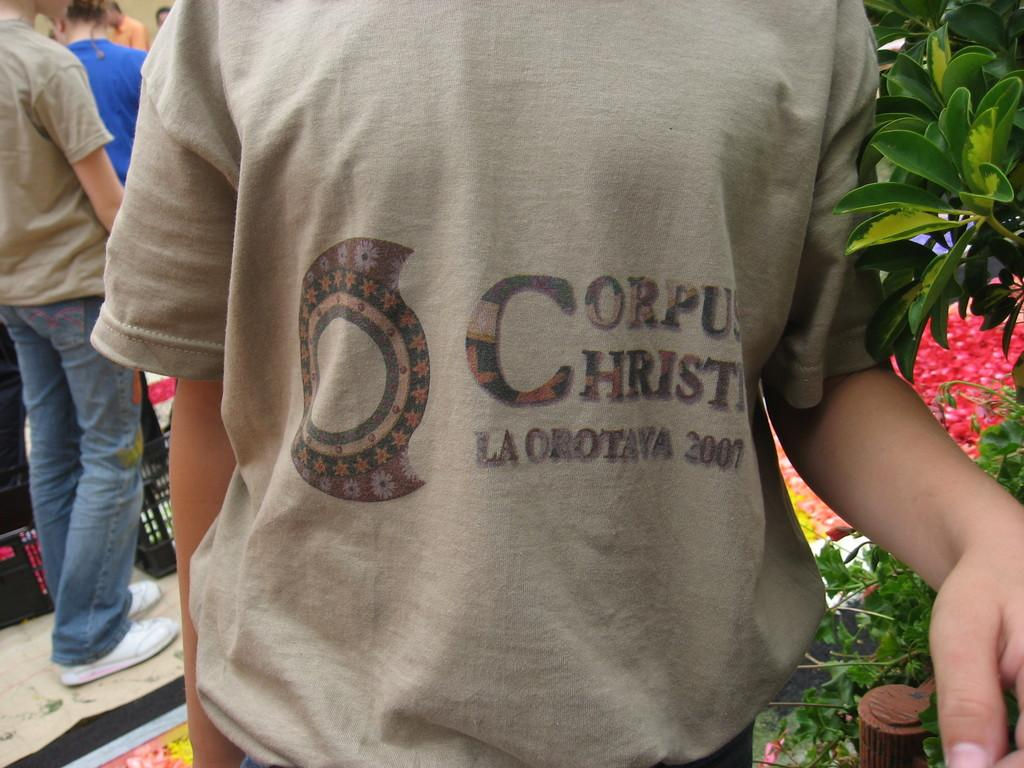How many people are in the image? There is a group of people in the image. What are the people doing in the image? The people are standing on the floor. What type of vegetation can be seen in the image? Leaves are present in the image. What is visible in the background of the image? There is a wall in the background of the image. What degree of temperature is being maintained in the image? There is no information about temperature in the image, so it cannot be determined. 